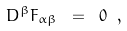<formula> <loc_0><loc_0><loc_500><loc_500>D ^ { \beta } F _ { \alpha \beta } \ = \ 0 \ ,</formula> 